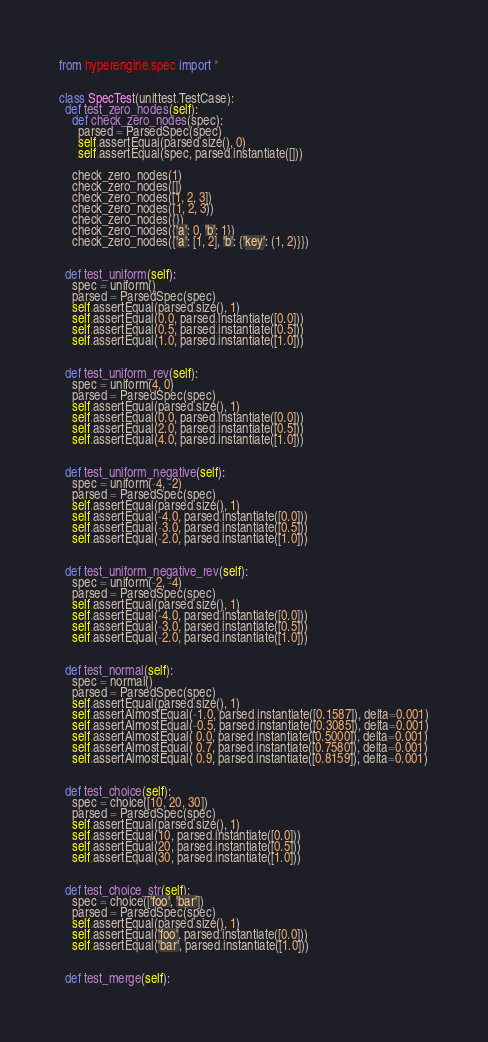<code> <loc_0><loc_0><loc_500><loc_500><_Python_>
from hyperengine.spec import *


class SpecTest(unittest.TestCase):
  def test_zero_nodes(self):
    def check_zero_nodes(spec):
      parsed = ParsedSpec(spec)
      self.assertEqual(parsed.size(), 0)
      self.assertEqual(spec, parsed.instantiate([]))
    
    check_zero_nodes(1)
    check_zero_nodes([])
    check_zero_nodes([1, 2, 3])
    check_zero_nodes((1, 2, 3))
    check_zero_nodes({})
    check_zero_nodes({'a': 0, 'b': 1})
    check_zero_nodes({'a': [1, 2], 'b': {'key': (1, 2)}})


  def test_uniform(self):
    spec = uniform()
    parsed = ParsedSpec(spec)
    self.assertEqual(parsed.size(), 1)
    self.assertEqual(0.0, parsed.instantiate([0.0]))
    self.assertEqual(0.5, parsed.instantiate([0.5]))
    self.assertEqual(1.0, parsed.instantiate([1.0]))


  def test_uniform_rev(self):
    spec = uniform(4, 0)
    parsed = ParsedSpec(spec)
    self.assertEqual(parsed.size(), 1)
    self.assertEqual(0.0, parsed.instantiate([0.0]))
    self.assertEqual(2.0, parsed.instantiate([0.5]))
    self.assertEqual(4.0, parsed.instantiate([1.0]))


  def test_uniform_negative(self):
    spec = uniform(-4, -2)
    parsed = ParsedSpec(spec)
    self.assertEqual(parsed.size(), 1)
    self.assertEqual(-4.0, parsed.instantiate([0.0]))
    self.assertEqual(-3.0, parsed.instantiate([0.5]))
    self.assertEqual(-2.0, parsed.instantiate([1.0]))


  def test_uniform_negative_rev(self):
    spec = uniform(-2, -4)
    parsed = ParsedSpec(spec)
    self.assertEqual(parsed.size(), 1)
    self.assertEqual(-4.0, parsed.instantiate([0.0]))
    self.assertEqual(-3.0, parsed.instantiate([0.5]))
    self.assertEqual(-2.0, parsed.instantiate([1.0]))


  def test_normal(self):
    spec = normal()
    parsed = ParsedSpec(spec)
    self.assertEqual(parsed.size(), 1)
    self.assertAlmostEqual(-1.0, parsed.instantiate([0.1587]), delta=0.001)
    self.assertAlmostEqual(-0.5, parsed.instantiate([0.3085]), delta=0.001)
    self.assertAlmostEqual( 0.0, parsed.instantiate([0.5000]), delta=0.001)
    self.assertAlmostEqual( 0.7, parsed.instantiate([0.7580]), delta=0.001)
    self.assertAlmostEqual( 0.9, parsed.instantiate([0.8159]), delta=0.001)


  def test_choice(self):
    spec = choice([10, 20, 30])
    parsed = ParsedSpec(spec)
    self.assertEqual(parsed.size(), 1)
    self.assertEqual(10, parsed.instantiate([0.0]))
    self.assertEqual(20, parsed.instantiate([0.5]))
    self.assertEqual(30, parsed.instantiate([1.0]))


  def test_choice_str(self):
    spec = choice(['foo', 'bar'])
    parsed = ParsedSpec(spec)
    self.assertEqual(parsed.size(), 1)
    self.assertEqual('foo', parsed.instantiate([0.0]))
    self.assertEqual('bar', parsed.instantiate([1.0]))


  def test_merge(self):</code> 